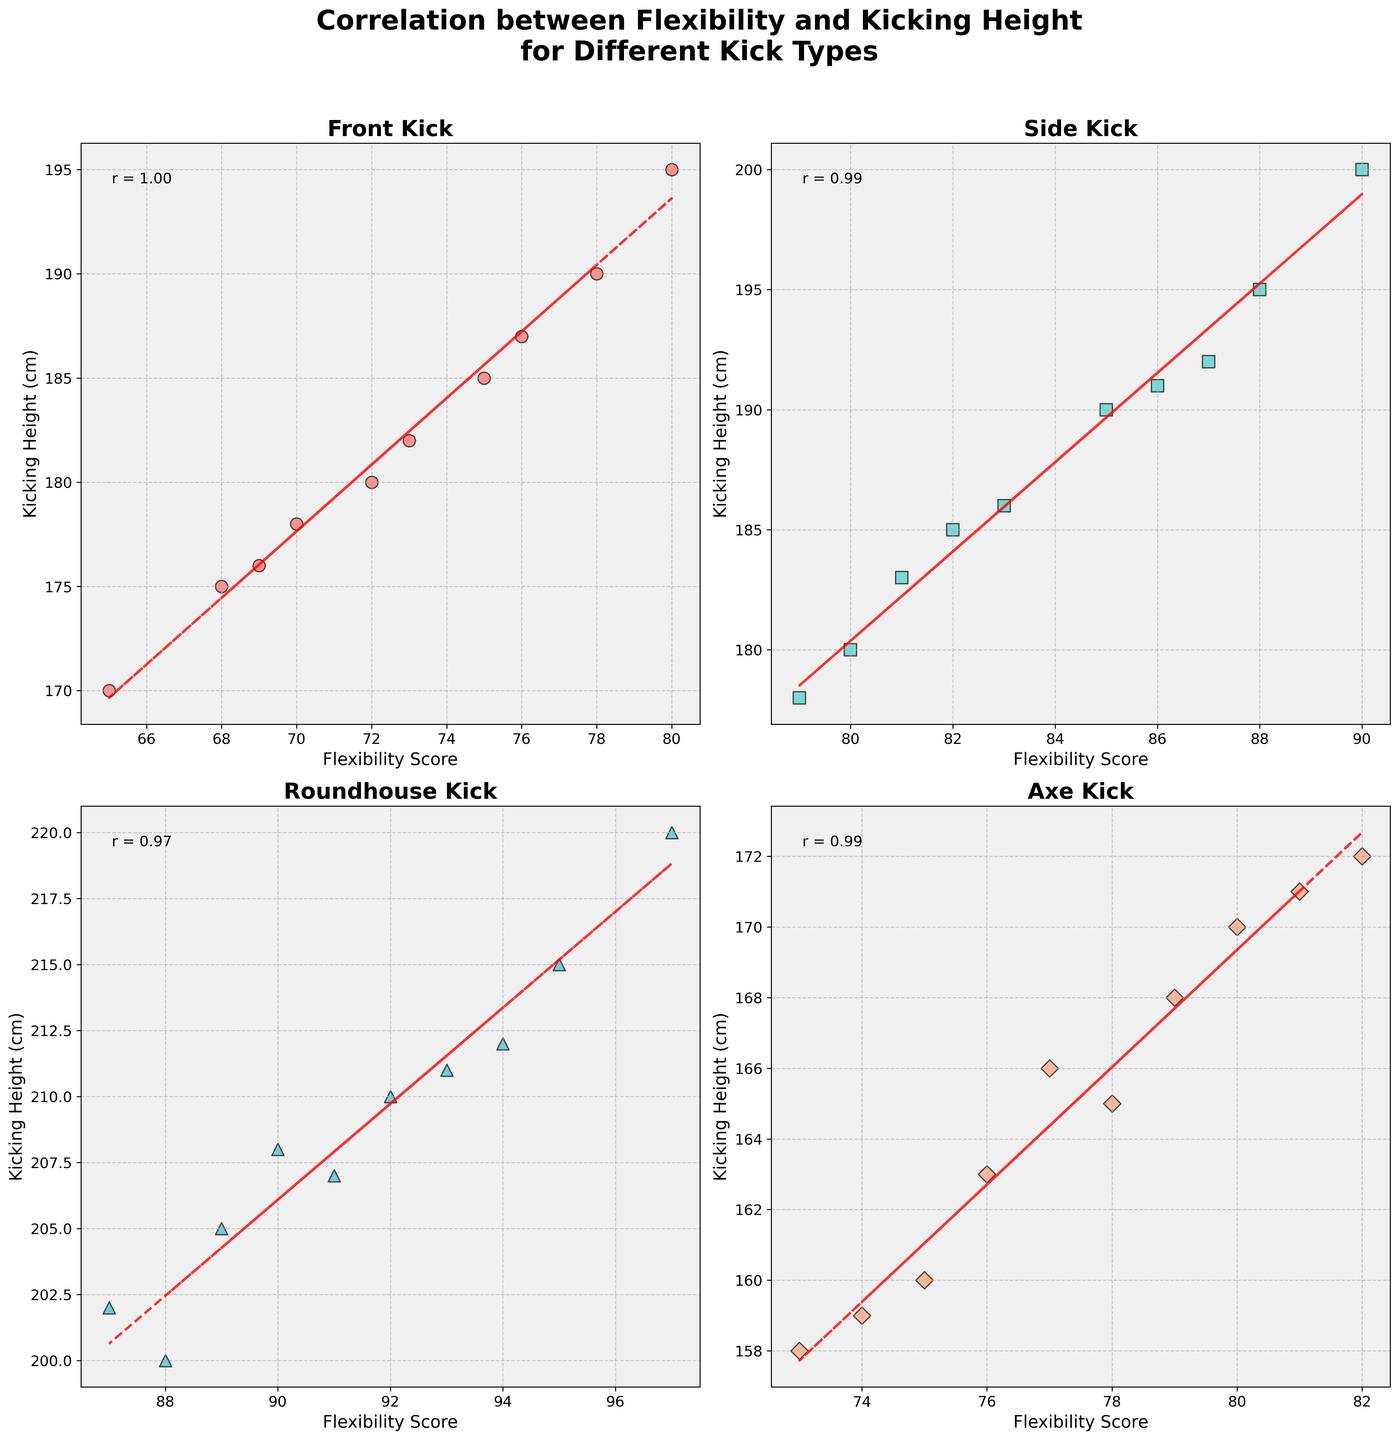How does the correlation coefficient for the Front Kick compare to the correlation coefficient for the Axe Kick? Inspect the annotated correlation coefficients (r values) for both the Front Kick and Axe Kick subplots. The Front Kick has one value, and the Axe Kick has another. Compare these two numbers.
Answer: The Front Kick has a higher correlation coefficient than the Axe Kick What is the trendline direction for the Side Kick's scatter plot? Observe the side kick scatter plot and look at the trendline (red dashed line). Notice the direction in which the line moves from left to right.
Answer: The trendline is upward, indicating a positive correlation Which kick type shows the highest kicking height? Identify each subplot and locate the individual with the highest kicking height across all scatter plots. You may find this by looking at the highest point on the y-axis across subplots.
Answer: Roundhouse Kick Do the Roundhouse and Side Kicks exhibit a positive, negative, or no correlation between flexibility score and kicking height? Look at the trendlines in the scatter plots for both Roundhouse and Side Kicks. If the trendline is upward, it indicates a positive correlation; downward indicates negative, and flat means no correlation.
Answer: Positive correlation Among Front Kick, Side Kick, Axe Kick, and Roundhouse Kick, which type has the least apparent spread in flexibility scores? Compare the range (width) of flexibility scores on the x-axis across all subplots. Identify which kick type's scores are most tightly clustered.
Answer: Front Kick Which kick type has the broadest range of flexibility scores? Assess the range of flexibility scores on the x-axis in each subplot. The type where the x-axis values spread out over the widest range has the broadest range of flexibility scores.
Answer: Roundhouse Kick What is the range of kicking heights for the Axe Kick? Examine the y-axis on the Axe Kick subplot, noting the highest and lowest points (uppermost and lowest dots). Subtract the lowest kicking height from the highest.
Answer: 62 cm (from 158 to 220 cm) For the Front Kick scatter plot, how does the highest kicking height compare to the highest kicking height of the Side Kick? Look at the highest points on the y-axis of both the Front Kick and Side Kick subplots and compare these values directly.
Answer: The Side Kick has a higher maximum kicking height (200 cm vs. 195 cm) Which kick type has the steepest trendline slope? Visually compare the angles of the trendlines in each subplot. The steeper the trendline, the larger the slope.
Answer: Roundhouse Kick 